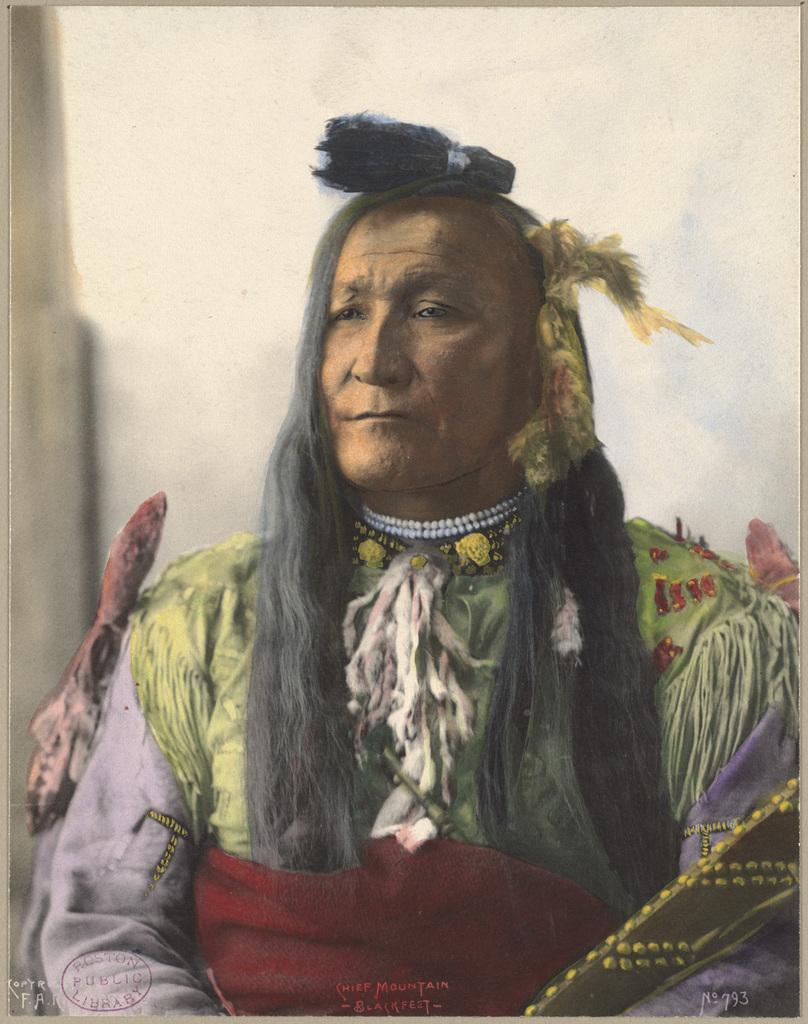In one or two sentences, can you explain what this image depicts? In this picture there is a painting. In the painting there is a woman who is wearing a dress and locket. In the back I can see the wall. 